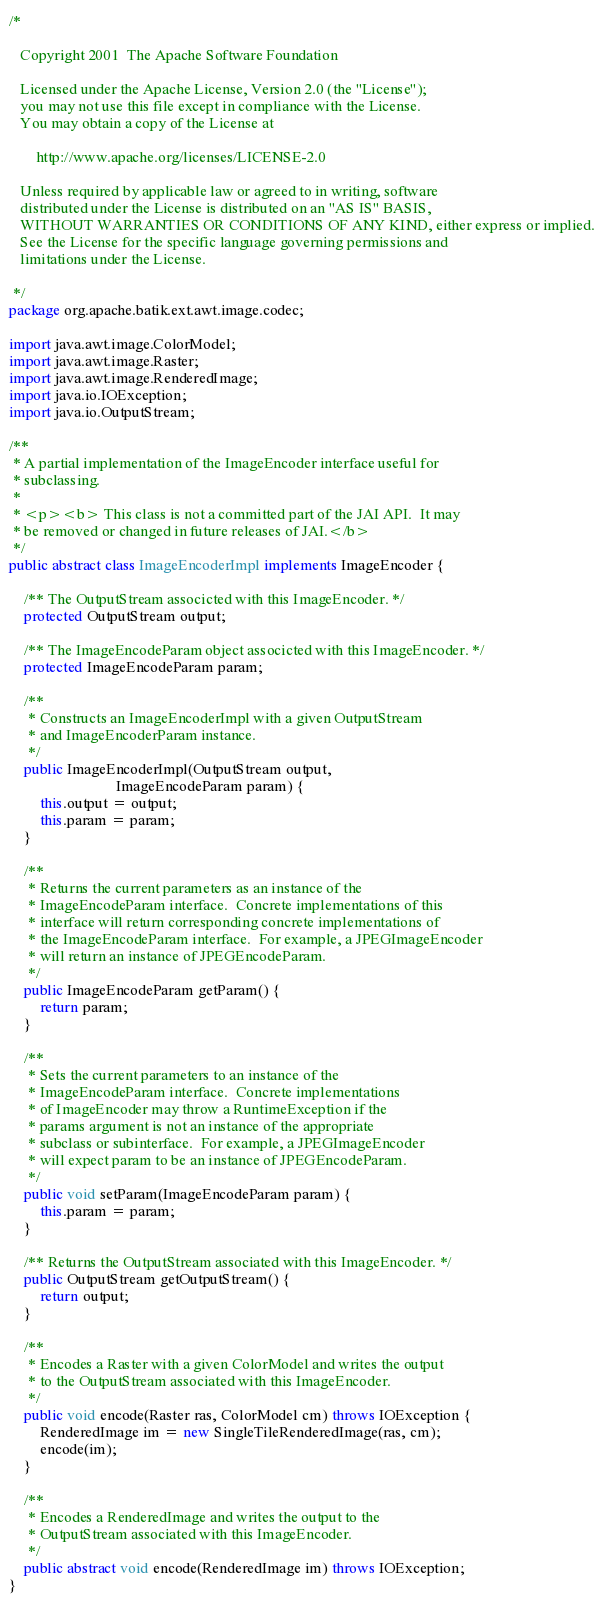<code> <loc_0><loc_0><loc_500><loc_500><_Java_>/*

   Copyright 2001  The Apache Software Foundation 

   Licensed under the Apache License, Version 2.0 (the "License");
   you may not use this file except in compliance with the License.
   You may obtain a copy of the License at

       http://www.apache.org/licenses/LICENSE-2.0

   Unless required by applicable law or agreed to in writing, software
   distributed under the License is distributed on an "AS IS" BASIS,
   WITHOUT WARRANTIES OR CONDITIONS OF ANY KIND, either express or implied.
   See the License for the specific language governing permissions and
   limitations under the License.

 */
package org.apache.batik.ext.awt.image.codec;

import java.awt.image.ColorModel;
import java.awt.image.Raster;
import java.awt.image.RenderedImage;
import java.io.IOException;
import java.io.OutputStream;

/**
 * A partial implementation of the ImageEncoder interface useful for
 * subclassing.
 *
 * <p><b> This class is not a committed part of the JAI API.  It may
 * be removed or changed in future releases of JAI.</b>
 */
public abstract class ImageEncoderImpl implements ImageEncoder {
    
    /** The OutputStream associcted with this ImageEncoder. */
    protected OutputStream output;

    /** The ImageEncodeParam object associcted with this ImageEncoder. */
    protected ImageEncodeParam param;

    /**
     * Constructs an ImageEncoderImpl with a given OutputStream
     * and ImageEncoderParam instance.
     */
    public ImageEncoderImpl(OutputStream output,
                            ImageEncodeParam param) {
        this.output = output;
        this.param = param;
    }

    /**
     * Returns the current parameters as an instance of the
     * ImageEncodeParam interface.  Concrete implementations of this
     * interface will return corresponding concrete implementations of
     * the ImageEncodeParam interface.  For example, a JPEGImageEncoder
     * will return an instance of JPEGEncodeParam.
     */
    public ImageEncodeParam getParam() {
        return param;
    }

    /**
     * Sets the current parameters to an instance of the 
     * ImageEncodeParam interface.  Concrete implementations
     * of ImageEncoder may throw a RuntimeException if the
     * params argument is not an instance of the appropriate
     * subclass or subinterface.  For example, a JPEGImageEncoder
     * will expect param to be an instance of JPEGEncodeParam.
     */
    public void setParam(ImageEncodeParam param) {
        this.param = param;
    }

    /** Returns the OutputStream associated with this ImageEncoder. */
    public OutputStream getOutputStream() {
        return output;
    }
    
    /**
     * Encodes a Raster with a given ColorModel and writes the output
     * to the OutputStream associated with this ImageEncoder.
     */
    public void encode(Raster ras, ColorModel cm) throws IOException {
        RenderedImage im = new SingleTileRenderedImage(ras, cm);
        encode(im);
    }

    /**
     * Encodes a RenderedImage and writes the output to the
     * OutputStream associated with this ImageEncoder.
     */
    public abstract void encode(RenderedImage im) throws IOException;
}
</code> 